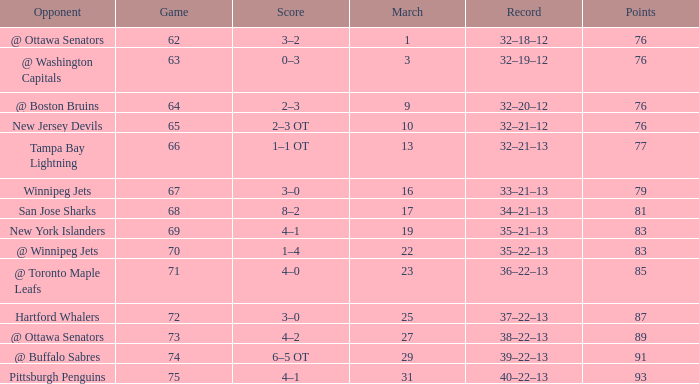Which Game is the lowest one that has a Score of 2–3 ot, and Points larger than 76? None. 